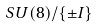Convert formula to latex. <formula><loc_0><loc_0><loc_500><loc_500>S U ( 8 ) / \{ \pm I \}</formula> 